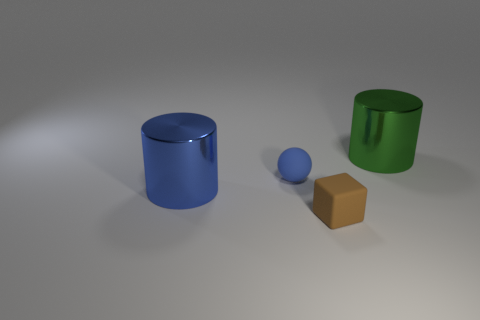Add 4 cyan rubber cylinders. How many objects exist? 8 Subtract all balls. How many objects are left? 3 Subtract 0 brown balls. How many objects are left? 4 Subtract all tiny rubber spheres. Subtract all small rubber spheres. How many objects are left? 2 Add 4 brown matte things. How many brown matte things are left? 5 Add 1 gray cylinders. How many gray cylinders exist? 1 